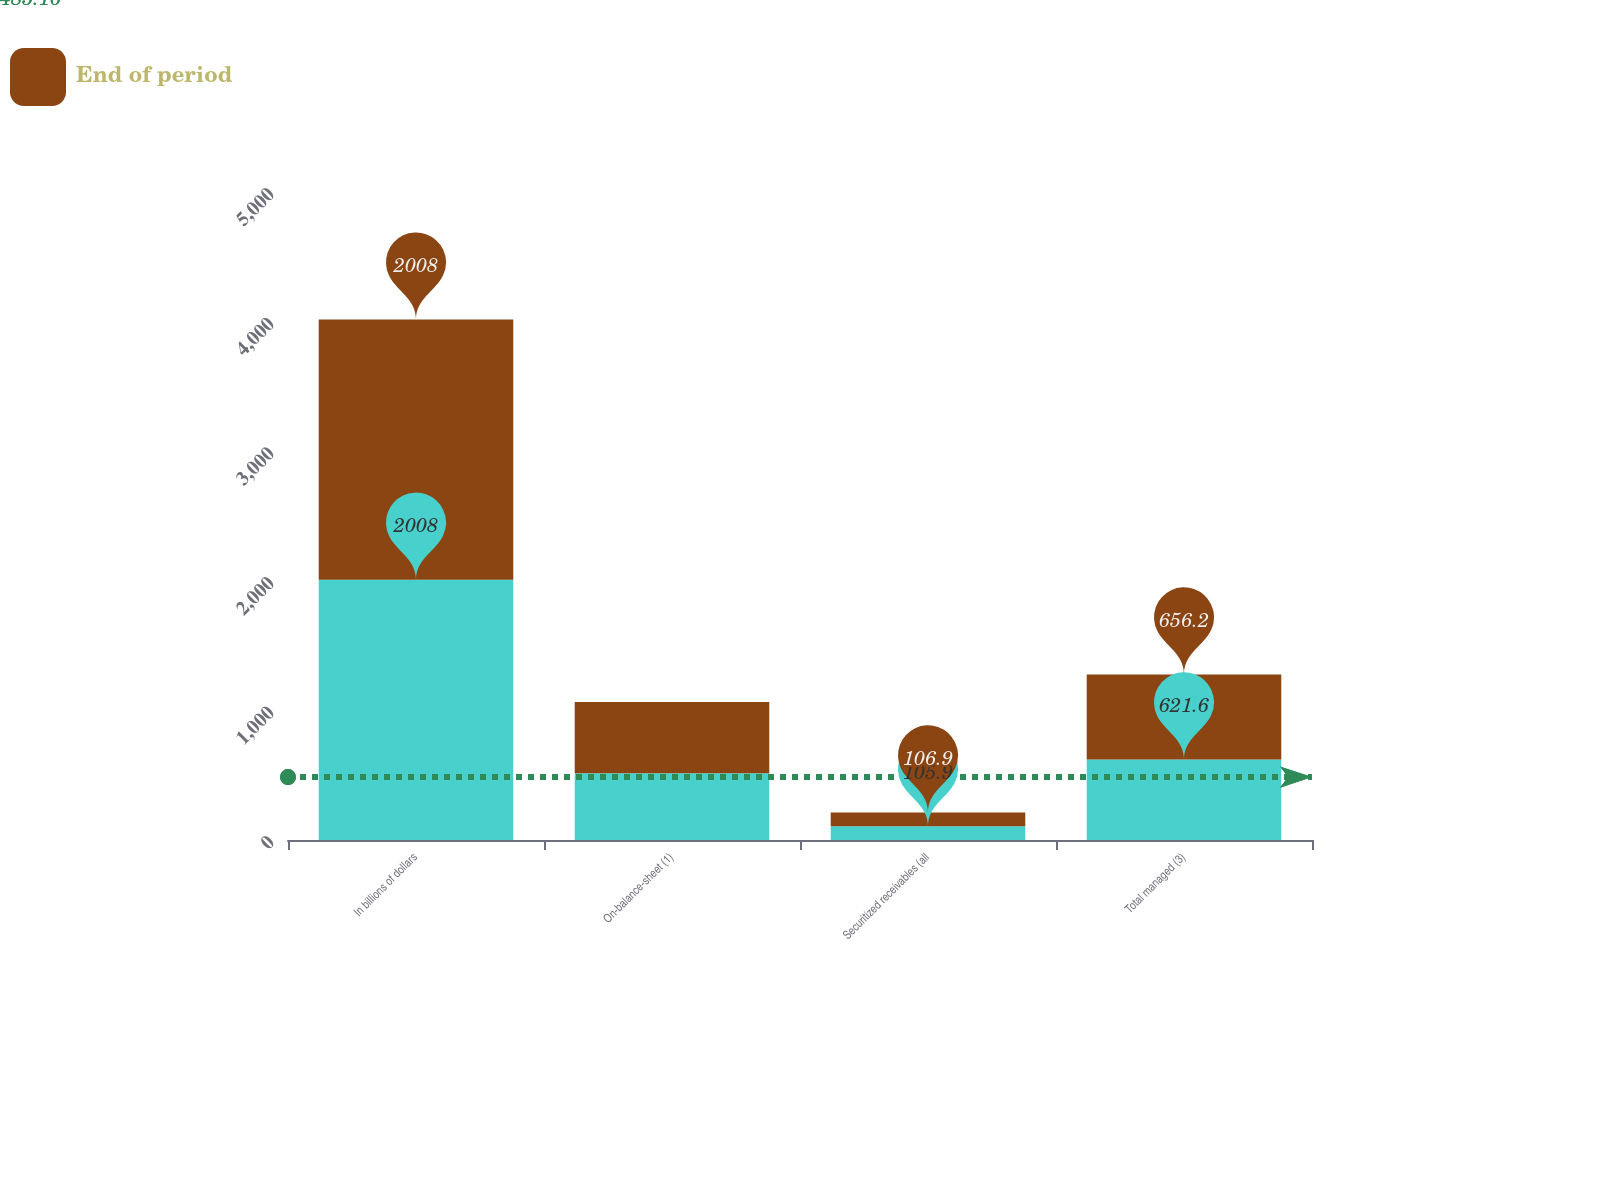Convert chart to OTSL. <chart><loc_0><loc_0><loc_500><loc_500><stacked_bar_chart><ecel><fcel>In billions of dollars<fcel>On-balance-sheet (1)<fcel>Securitized receivables (all<fcel>Total managed (3)<nl><fcel>nan<fcel>2008<fcel>515.7<fcel>105.9<fcel>621.6<nl><fcel>End of period<fcel>2008<fcel>548.8<fcel>106.9<fcel>656.2<nl></chart> 